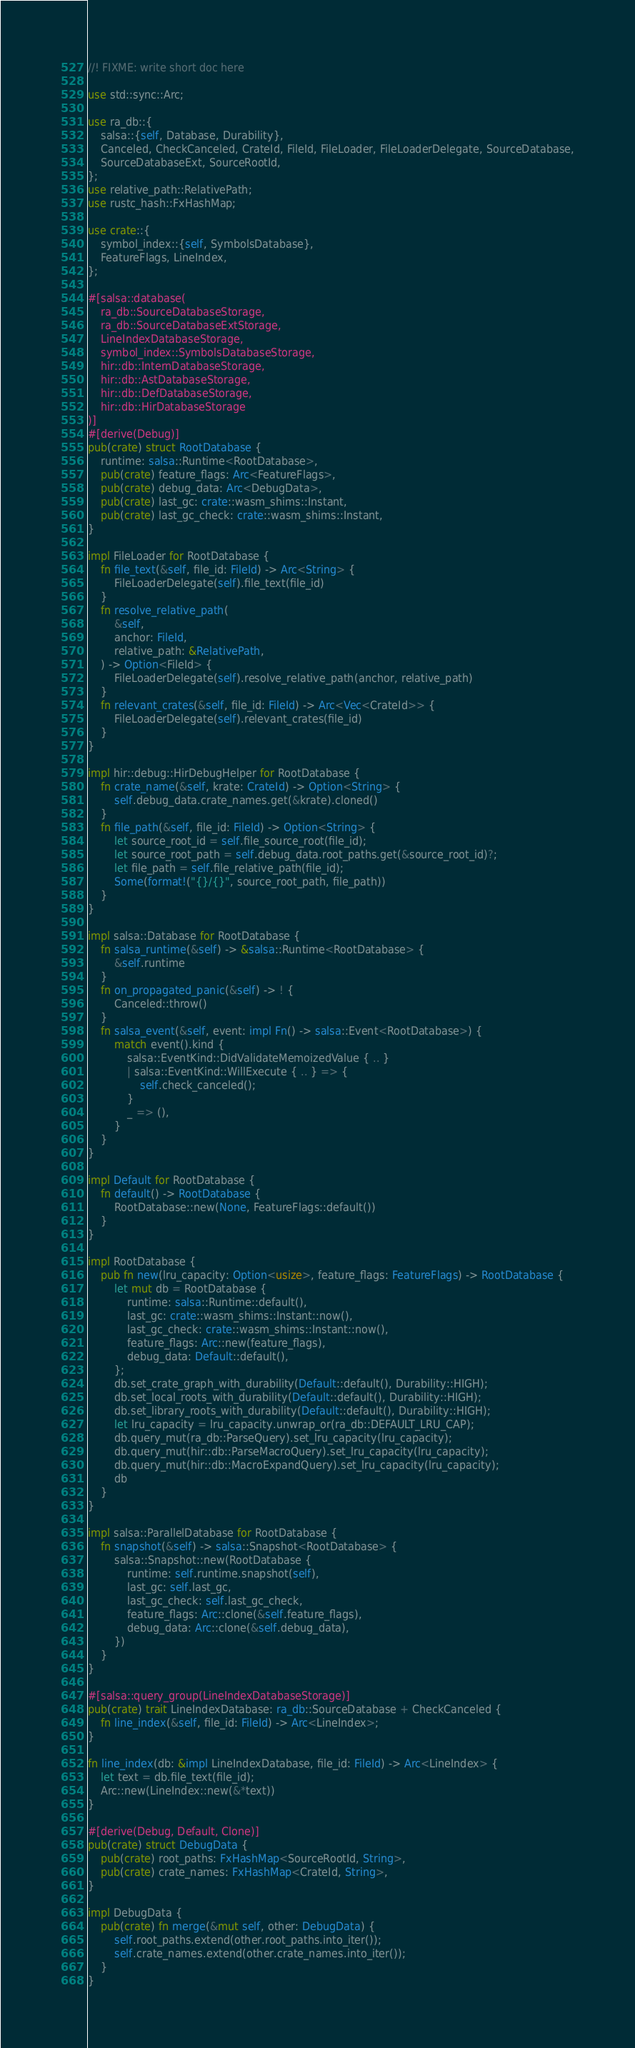<code> <loc_0><loc_0><loc_500><loc_500><_Rust_>//! FIXME: write short doc here

use std::sync::Arc;

use ra_db::{
    salsa::{self, Database, Durability},
    Canceled, CheckCanceled, CrateId, FileId, FileLoader, FileLoaderDelegate, SourceDatabase,
    SourceDatabaseExt, SourceRootId,
};
use relative_path::RelativePath;
use rustc_hash::FxHashMap;

use crate::{
    symbol_index::{self, SymbolsDatabase},
    FeatureFlags, LineIndex,
};

#[salsa::database(
    ra_db::SourceDatabaseStorage,
    ra_db::SourceDatabaseExtStorage,
    LineIndexDatabaseStorage,
    symbol_index::SymbolsDatabaseStorage,
    hir::db::InternDatabaseStorage,
    hir::db::AstDatabaseStorage,
    hir::db::DefDatabaseStorage,
    hir::db::HirDatabaseStorage
)]
#[derive(Debug)]
pub(crate) struct RootDatabase {
    runtime: salsa::Runtime<RootDatabase>,
    pub(crate) feature_flags: Arc<FeatureFlags>,
    pub(crate) debug_data: Arc<DebugData>,
    pub(crate) last_gc: crate::wasm_shims::Instant,
    pub(crate) last_gc_check: crate::wasm_shims::Instant,
}

impl FileLoader for RootDatabase {
    fn file_text(&self, file_id: FileId) -> Arc<String> {
        FileLoaderDelegate(self).file_text(file_id)
    }
    fn resolve_relative_path(
        &self,
        anchor: FileId,
        relative_path: &RelativePath,
    ) -> Option<FileId> {
        FileLoaderDelegate(self).resolve_relative_path(anchor, relative_path)
    }
    fn relevant_crates(&self, file_id: FileId) -> Arc<Vec<CrateId>> {
        FileLoaderDelegate(self).relevant_crates(file_id)
    }
}

impl hir::debug::HirDebugHelper for RootDatabase {
    fn crate_name(&self, krate: CrateId) -> Option<String> {
        self.debug_data.crate_names.get(&krate).cloned()
    }
    fn file_path(&self, file_id: FileId) -> Option<String> {
        let source_root_id = self.file_source_root(file_id);
        let source_root_path = self.debug_data.root_paths.get(&source_root_id)?;
        let file_path = self.file_relative_path(file_id);
        Some(format!("{}/{}", source_root_path, file_path))
    }
}

impl salsa::Database for RootDatabase {
    fn salsa_runtime(&self) -> &salsa::Runtime<RootDatabase> {
        &self.runtime
    }
    fn on_propagated_panic(&self) -> ! {
        Canceled::throw()
    }
    fn salsa_event(&self, event: impl Fn() -> salsa::Event<RootDatabase>) {
        match event().kind {
            salsa::EventKind::DidValidateMemoizedValue { .. }
            | salsa::EventKind::WillExecute { .. } => {
                self.check_canceled();
            }
            _ => (),
        }
    }
}

impl Default for RootDatabase {
    fn default() -> RootDatabase {
        RootDatabase::new(None, FeatureFlags::default())
    }
}

impl RootDatabase {
    pub fn new(lru_capacity: Option<usize>, feature_flags: FeatureFlags) -> RootDatabase {
        let mut db = RootDatabase {
            runtime: salsa::Runtime::default(),
            last_gc: crate::wasm_shims::Instant::now(),
            last_gc_check: crate::wasm_shims::Instant::now(),
            feature_flags: Arc::new(feature_flags),
            debug_data: Default::default(),
        };
        db.set_crate_graph_with_durability(Default::default(), Durability::HIGH);
        db.set_local_roots_with_durability(Default::default(), Durability::HIGH);
        db.set_library_roots_with_durability(Default::default(), Durability::HIGH);
        let lru_capacity = lru_capacity.unwrap_or(ra_db::DEFAULT_LRU_CAP);
        db.query_mut(ra_db::ParseQuery).set_lru_capacity(lru_capacity);
        db.query_mut(hir::db::ParseMacroQuery).set_lru_capacity(lru_capacity);
        db.query_mut(hir::db::MacroExpandQuery).set_lru_capacity(lru_capacity);
        db
    }
}

impl salsa::ParallelDatabase for RootDatabase {
    fn snapshot(&self) -> salsa::Snapshot<RootDatabase> {
        salsa::Snapshot::new(RootDatabase {
            runtime: self.runtime.snapshot(self),
            last_gc: self.last_gc,
            last_gc_check: self.last_gc_check,
            feature_flags: Arc::clone(&self.feature_flags),
            debug_data: Arc::clone(&self.debug_data),
        })
    }
}

#[salsa::query_group(LineIndexDatabaseStorage)]
pub(crate) trait LineIndexDatabase: ra_db::SourceDatabase + CheckCanceled {
    fn line_index(&self, file_id: FileId) -> Arc<LineIndex>;
}

fn line_index(db: &impl LineIndexDatabase, file_id: FileId) -> Arc<LineIndex> {
    let text = db.file_text(file_id);
    Arc::new(LineIndex::new(&*text))
}

#[derive(Debug, Default, Clone)]
pub(crate) struct DebugData {
    pub(crate) root_paths: FxHashMap<SourceRootId, String>,
    pub(crate) crate_names: FxHashMap<CrateId, String>,
}

impl DebugData {
    pub(crate) fn merge(&mut self, other: DebugData) {
        self.root_paths.extend(other.root_paths.into_iter());
        self.crate_names.extend(other.crate_names.into_iter());
    }
}
</code> 